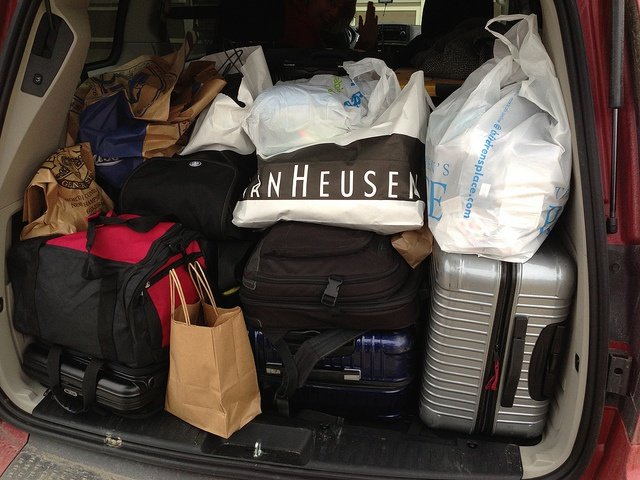Describe the objects in this image and their specific colors. I can see car in black, gray, lightgray, darkgray, and maroon tones, suitcase in maroon, black, gray, and darkgray tones, handbag in maroon, black, and brown tones, suitcase in maroon, black, and brown tones, and backpack in maroon, black, gray, and darkgray tones in this image. 